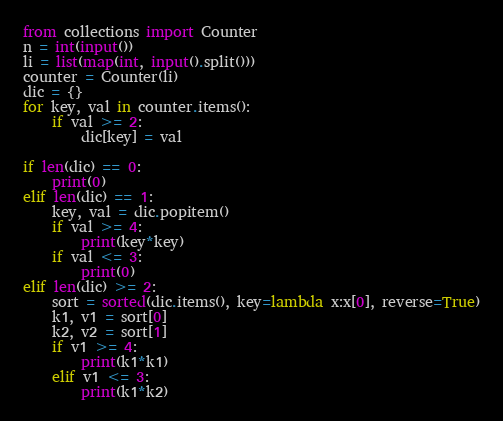<code> <loc_0><loc_0><loc_500><loc_500><_Python_>from collections import Counter
n = int(input())
li = list(map(int, input().split()))
counter = Counter(li)
dic = {}
for key, val in counter.items():
    if val >= 2:
        dic[key] = val

if len(dic) == 0:
    print(0)
elif len(dic) == 1:
    key, val = dic.popitem()
    if val >= 4:
        print(key*key)
    if val <= 3:
        print(0)
elif len(dic) >= 2:
    sort = sorted(dic.items(), key=lambda x:x[0], reverse=True)
    k1, v1 = sort[0]
    k2, v2 = sort[1]
    if v1 >= 4:
        print(k1*k1)
    elif v1 <= 3:
        print(k1*k2)</code> 